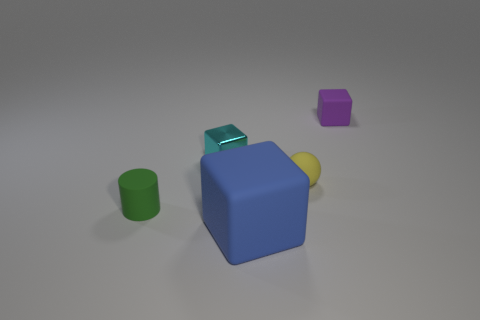Is there a small sphere that has the same material as the large blue object?
Make the answer very short. Yes. Are there the same number of blocks in front of the blue cube and rubber balls that are left of the green rubber object?
Make the answer very short. Yes. What size is the cube that is in front of the green matte thing?
Keep it short and to the point. Large. What is the material of the tiny cube in front of the small matte thing that is behind the cyan shiny block?
Provide a succinct answer. Metal. How many green rubber things are to the right of the small cube that is left of the matte block behind the tiny green rubber cylinder?
Your answer should be compact. 0. Is the material of the large blue block that is right of the green matte object the same as the tiny cube that is left of the tiny purple block?
Your response must be concise. No. What number of purple matte objects are the same shape as the blue object?
Your answer should be compact. 1. Is the number of rubber objects that are to the right of the yellow rubber object greater than the number of big gray rubber spheres?
Your answer should be compact. Yes. The small shiny thing that is left of the matte cube that is on the left side of the small block to the right of the big blue cube is what shape?
Make the answer very short. Cube. Is the shape of the small matte object in front of the yellow object the same as the tiny purple matte object that is to the right of the blue matte cube?
Provide a short and direct response. No. 